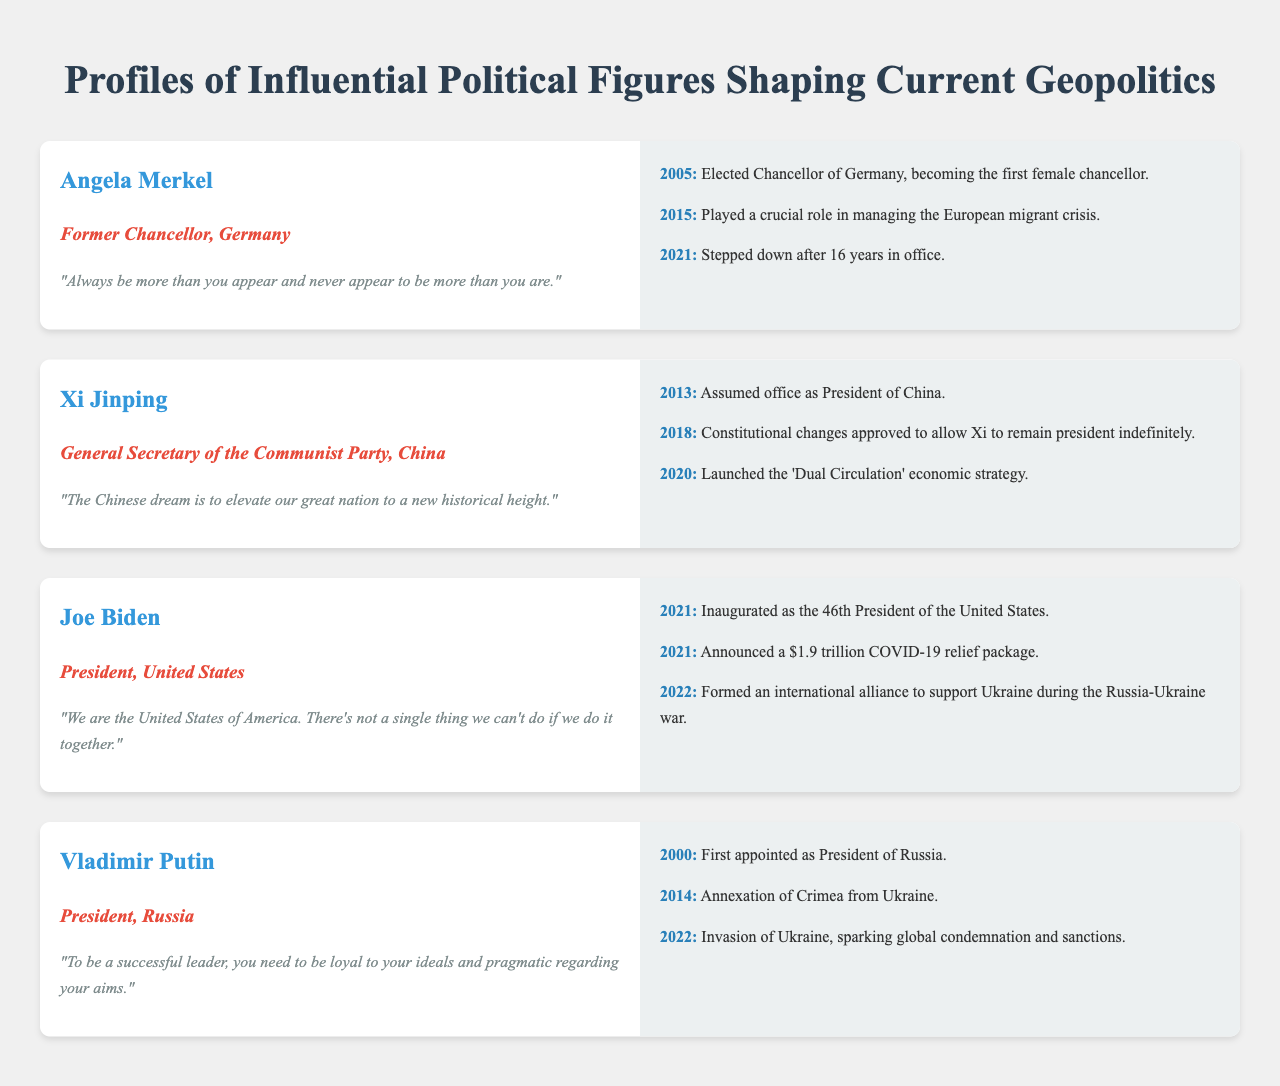What year was Angela Merkel elected Chancellor of Germany? Angela Merkel was elected Chancellor in 2005, as stated in her profile timeline.
Answer: 2005 What quote is attributed to Joe Biden? The quote attributed to Joe Biden in the document reflects his emphasis on unity and collaboration.
Answer: "We are the United States of America. There's not a single thing we can't do if we do it together." In what year did Xi Jinping assume office as President of China? The document specifies that Xi Jinping assumed office in 2013.
Answer: 2013 How many years did Angela Merkel serve as Chancellor before stepping down? Angela Merkel served as Chancellor for 16 years before stepping down in 2021.
Answer: 16 years Which significant event occurred during Vladimir Putin's presidency in 2014? The timeline mentions that in 2014, Vladimir Putin oversaw the annexation of Crimea from Ukraine.
Answer: Annexation of Crimea What economic strategy did Xi Jinping launch in 2020? The document notes that Xi Jinping launched the 'Dual Circulation' economic strategy in 2020.
Answer: 'Dual Circulation' What was a major focus of Joe Biden's presidency in 2021? The profile indicates that a major focus was announcing a $1.9 trillion COVID-19 relief package in 2021.
Answer: $1.9 trillion COVID-19 relief package What is the title of Xi Jinping’s leadership role in China? Xi Jinping holds the title of General Secretary of the Communist Party in China.
Answer: General Secretary of the Communist Party What phrase does Vladimir Putin use regarding leadership? Vladimir Putin emphasizes loyalty and pragmatism in his quote about being a successful leader.
Answer: "To be a successful leader, you need to be loyal to your ideals and pragmatic regarding your aims." 